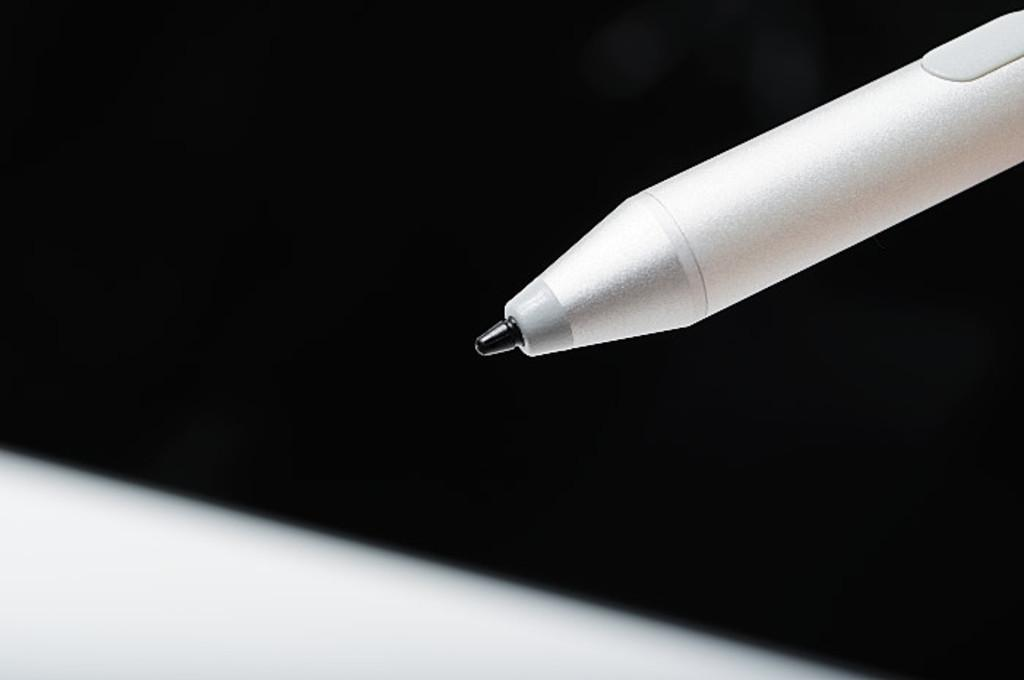What is the color of the pen in the image? The pen is white in color. Where is the pen located in the image? The pen is on the right side of the image. What can be observed about the background of the image? The background of the image is dark. What type of jewel is sparkling on the pen in the image? There is no jewel present on the pen in the image, and therefore no sparkling can be observed. 